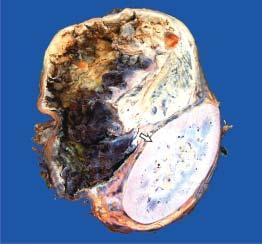does the specimen show compressed kidney at the lower end while the upper end shows a large spherical tumour separate from the kidney?
Answer the question using a single word or phrase. Yes 